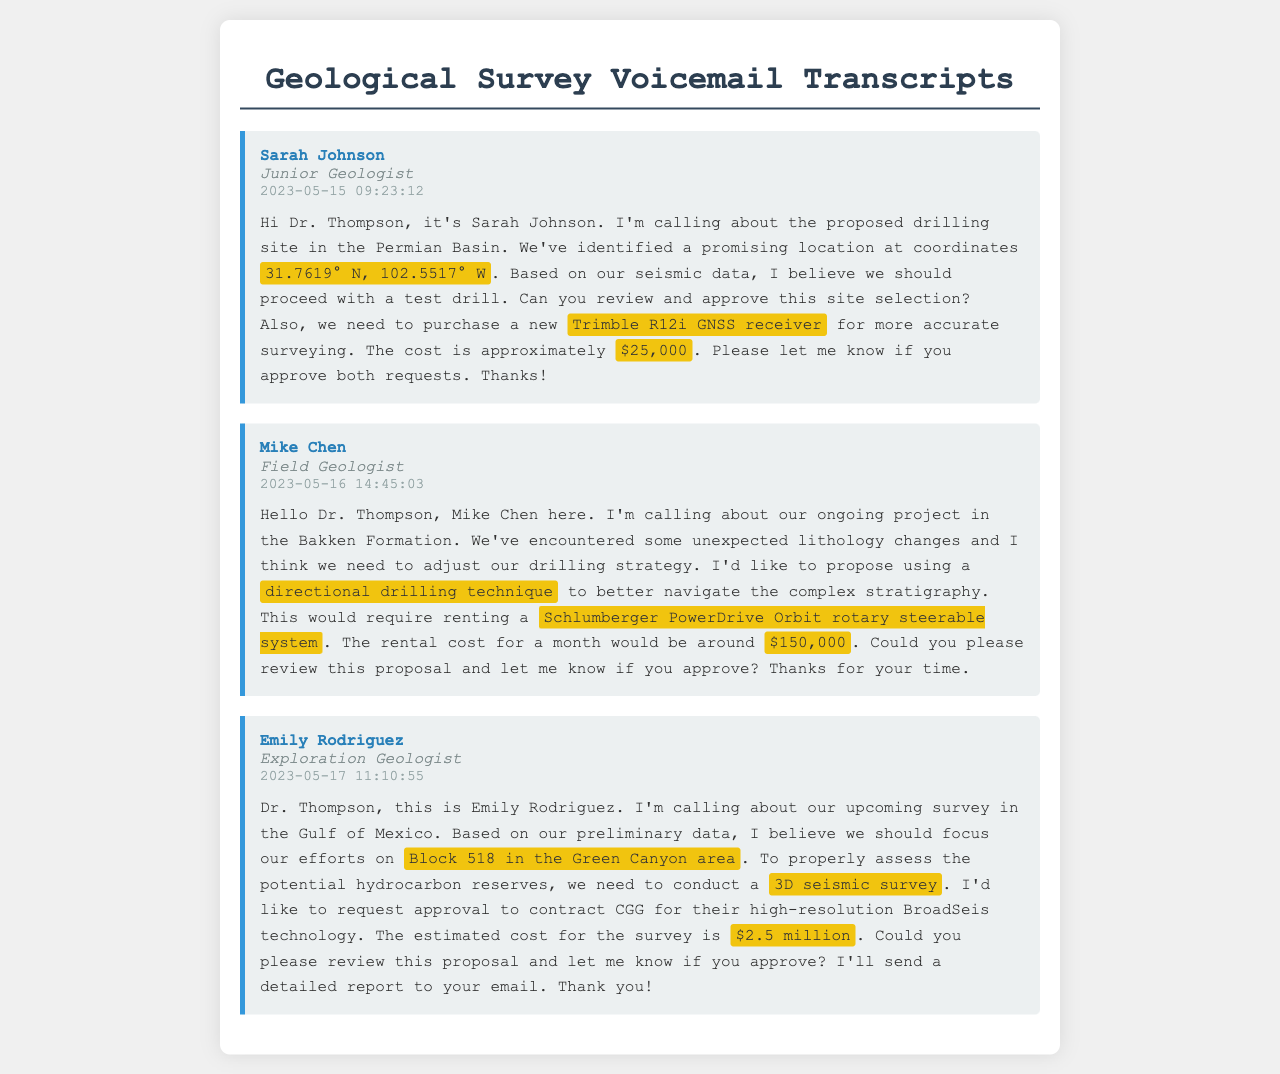What is the proposed drilling site location? Sarah Johnson mentioned the proposed drilling site coordinates, which are crucial for site verification.
Answer: 31.7619° N, 102.5517° W What is the cost of the Trimble R12i GNSS receiver? Sarah Johnson specified the approximate cost for the GNSS receiver necessary for accurate surveying.
Answer: $25,000 Who is requesting approval for the 3D seismic survey? Emily Rodriguez is the person requesting approval for the seismic survey based on her analysis of preliminary data.
Answer: Emily Rodriguez What technology is being proposed for the 3D seismic survey? Emily Rodriguez mentioned the use of CGG's high-resolution BroadSeis technology for the survey.
Answer: BroadSeis technology What is the rental cost for the Schlumberger PowerDrive Orbit? Mike Chen provided the rental cost for the directional drilling system he proposed in his voicemail.
Answer: $150,000 What is the focus area for Emily Rodriguez's upcoming survey? Emily Rodriguez specified Block 518 in the Green Canyon area as the focus for their survey efforts.
Answer: Block 518 in the Green Canyon area What date did Mike Chen leave his voicemail? The date on which Mike Chen left his voicemail is important for tracking project timing and decisions.
Answer: 2023-05-16 How much is the estimated cost for the seismic survey requested by Emily? The cost associated with the seismic survey proposal is a critical factor in budgeting for the project.
Answer: $2.5 million 